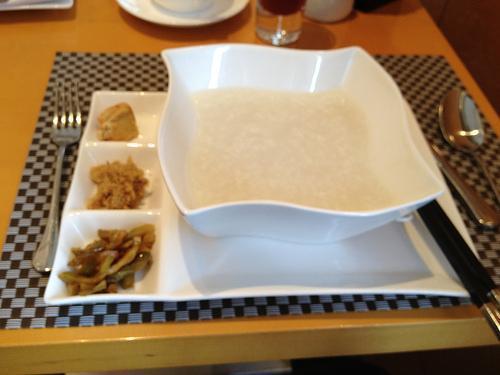How many bowls are there?
Give a very brief answer. 1. 